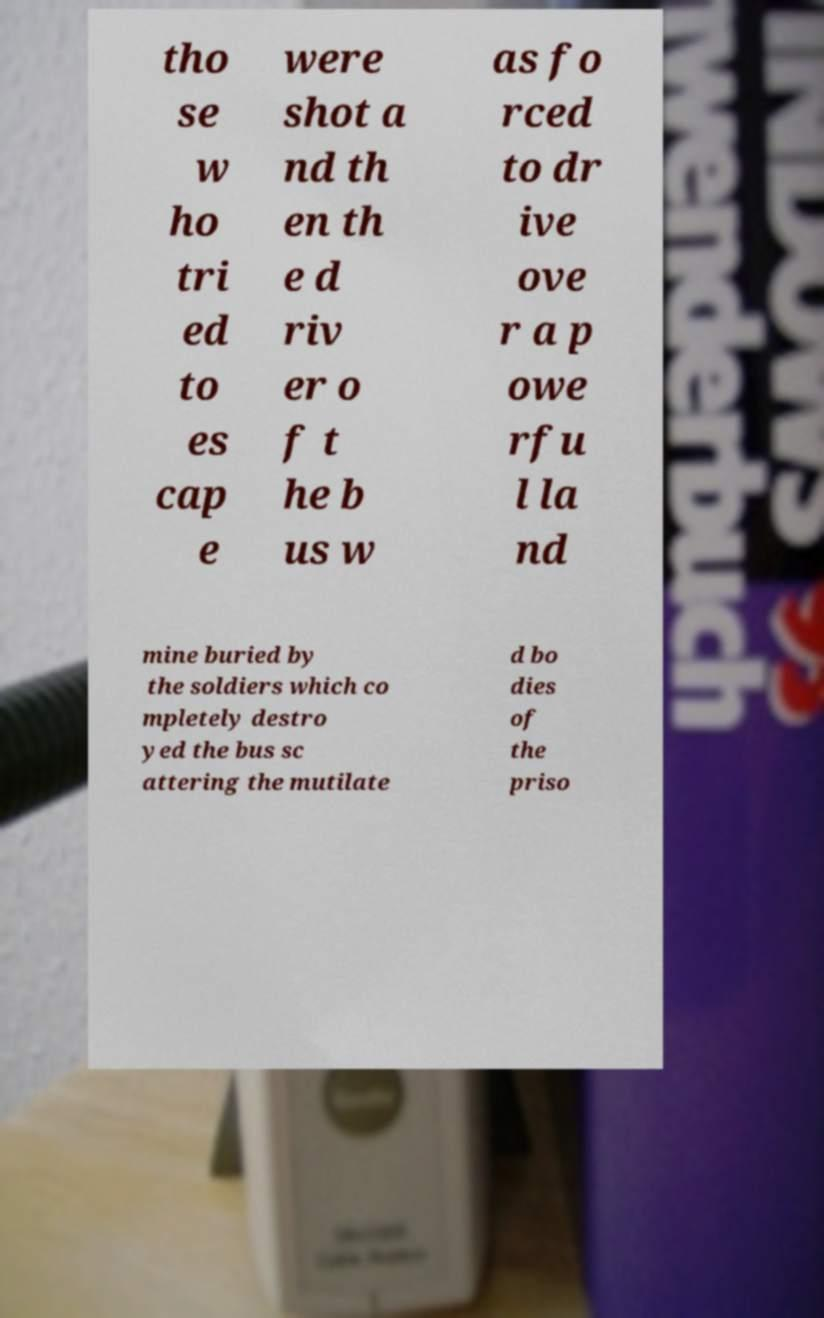What messages or text are displayed in this image? I need them in a readable, typed format. tho se w ho tri ed to es cap e were shot a nd th en th e d riv er o f t he b us w as fo rced to dr ive ove r a p owe rfu l la nd mine buried by the soldiers which co mpletely destro yed the bus sc attering the mutilate d bo dies of the priso 